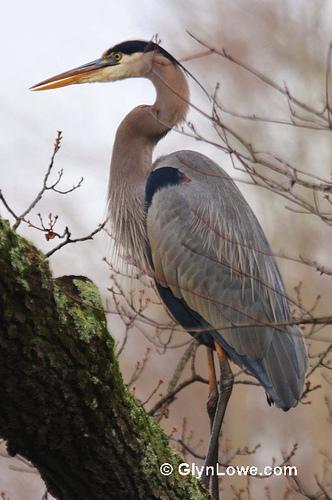How many birds are in the picture?
Give a very brief answer. 1. 